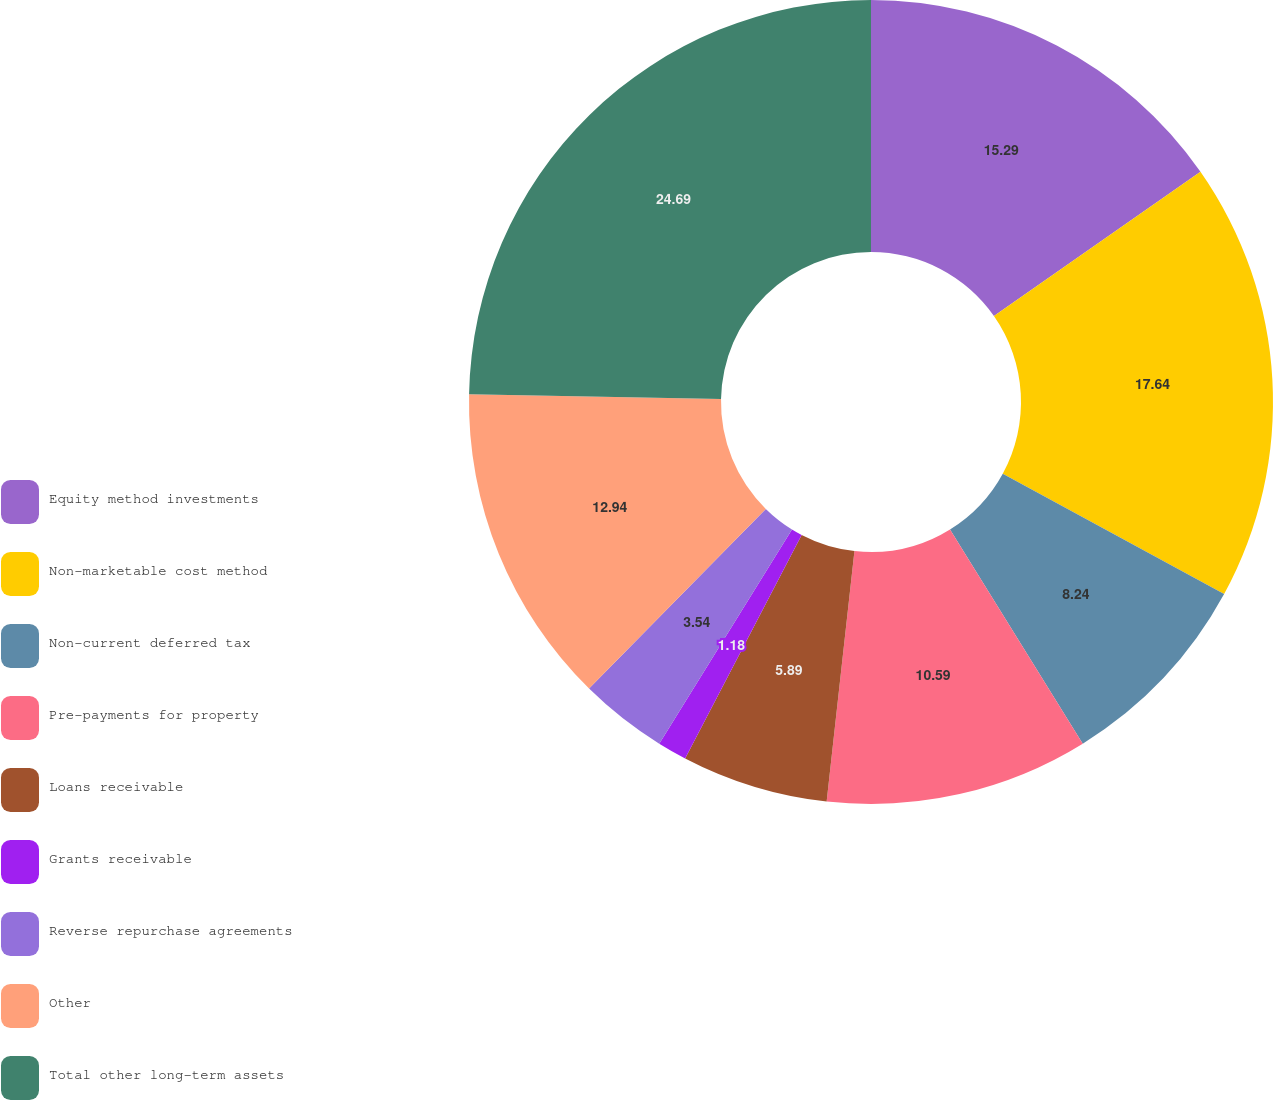<chart> <loc_0><loc_0><loc_500><loc_500><pie_chart><fcel>Equity method investments<fcel>Non-marketable cost method<fcel>Non-current deferred tax<fcel>Pre-payments for property<fcel>Loans receivable<fcel>Grants receivable<fcel>Reverse repurchase agreements<fcel>Other<fcel>Total other long-term assets<nl><fcel>15.29%<fcel>17.64%<fcel>8.24%<fcel>10.59%<fcel>5.89%<fcel>1.18%<fcel>3.54%<fcel>12.94%<fcel>24.69%<nl></chart> 